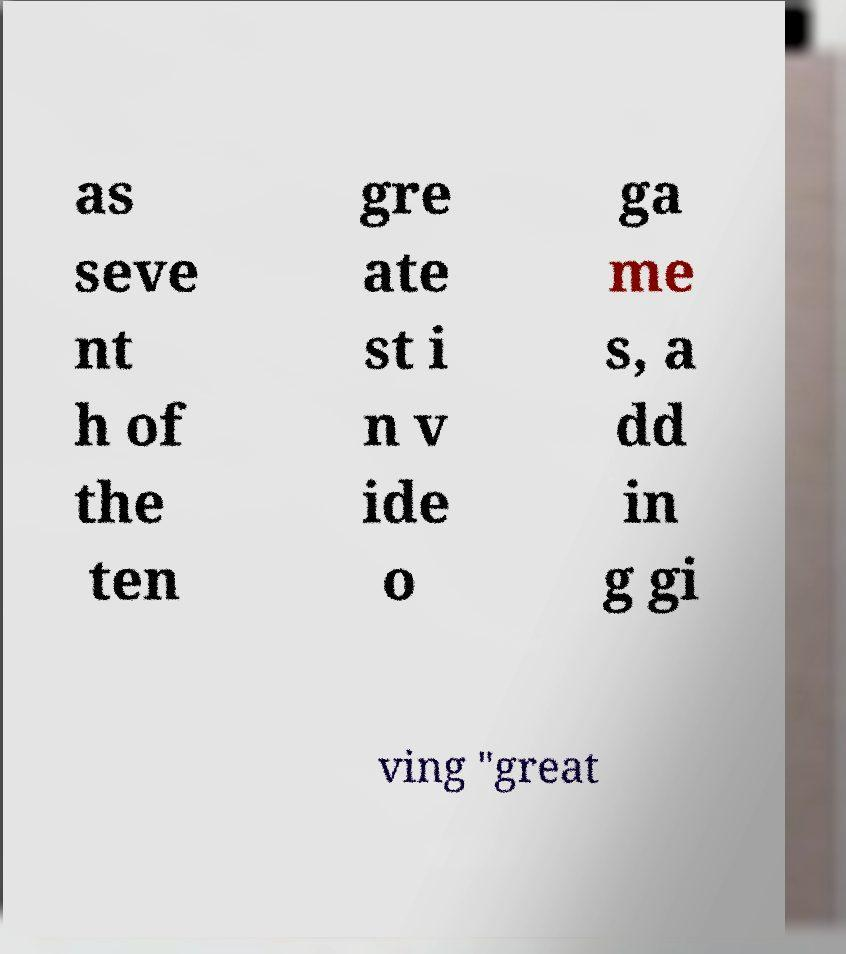Please read and relay the text visible in this image. What does it say? as seve nt h of the ten gre ate st i n v ide o ga me s, a dd in g gi ving "great 